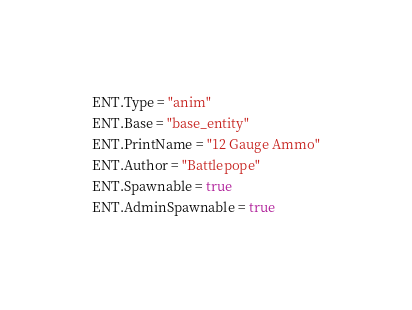Convert code to text. <code><loc_0><loc_0><loc_500><loc_500><_Lua_>ENT.Type = "anim"
ENT.Base = "base_entity"
ENT.PrintName = "12 Gauge Ammo"
ENT.Author = "Battlepope"
ENT.Spawnable = true
ENT.AdminSpawnable = true </code> 